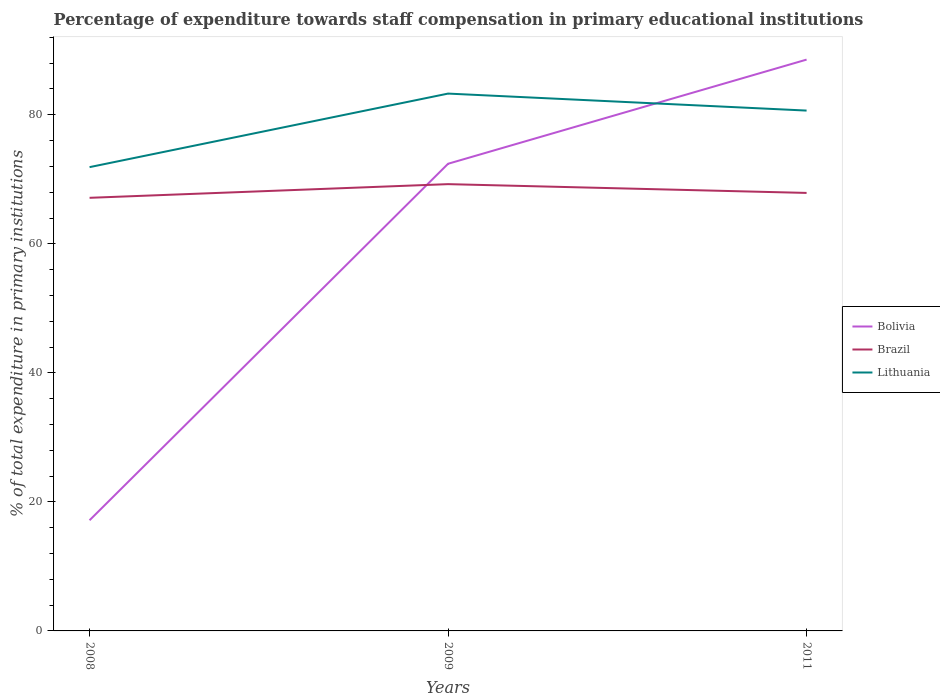How many different coloured lines are there?
Your answer should be compact. 3. Across all years, what is the maximum percentage of expenditure towards staff compensation in Bolivia?
Provide a short and direct response. 17.15. In which year was the percentage of expenditure towards staff compensation in Lithuania maximum?
Offer a very short reply. 2008. What is the total percentage of expenditure towards staff compensation in Bolivia in the graph?
Your answer should be very brief. -16.14. What is the difference between the highest and the second highest percentage of expenditure towards staff compensation in Brazil?
Offer a terse response. 2.12. Is the percentage of expenditure towards staff compensation in Brazil strictly greater than the percentage of expenditure towards staff compensation in Lithuania over the years?
Offer a very short reply. Yes. How many lines are there?
Your response must be concise. 3. What is the difference between two consecutive major ticks on the Y-axis?
Provide a short and direct response. 20. Are the values on the major ticks of Y-axis written in scientific E-notation?
Provide a succinct answer. No. Does the graph contain any zero values?
Give a very brief answer. No. How many legend labels are there?
Your answer should be compact. 3. What is the title of the graph?
Your answer should be very brief. Percentage of expenditure towards staff compensation in primary educational institutions. What is the label or title of the Y-axis?
Offer a very short reply. % of total expenditure in primary institutions. What is the % of total expenditure in primary institutions in Bolivia in 2008?
Make the answer very short. 17.15. What is the % of total expenditure in primary institutions of Brazil in 2008?
Offer a very short reply. 67.13. What is the % of total expenditure in primary institutions in Lithuania in 2008?
Keep it short and to the point. 71.89. What is the % of total expenditure in primary institutions of Bolivia in 2009?
Provide a succinct answer. 72.41. What is the % of total expenditure in primary institutions of Brazil in 2009?
Give a very brief answer. 69.25. What is the % of total expenditure in primary institutions in Lithuania in 2009?
Make the answer very short. 83.29. What is the % of total expenditure in primary institutions of Bolivia in 2011?
Your response must be concise. 88.55. What is the % of total expenditure in primary institutions in Brazil in 2011?
Your response must be concise. 67.89. What is the % of total expenditure in primary institutions in Lithuania in 2011?
Ensure brevity in your answer.  80.66. Across all years, what is the maximum % of total expenditure in primary institutions in Bolivia?
Provide a succinct answer. 88.55. Across all years, what is the maximum % of total expenditure in primary institutions of Brazil?
Keep it short and to the point. 69.25. Across all years, what is the maximum % of total expenditure in primary institutions in Lithuania?
Keep it short and to the point. 83.29. Across all years, what is the minimum % of total expenditure in primary institutions of Bolivia?
Provide a short and direct response. 17.15. Across all years, what is the minimum % of total expenditure in primary institutions of Brazil?
Offer a very short reply. 67.13. Across all years, what is the minimum % of total expenditure in primary institutions in Lithuania?
Keep it short and to the point. 71.89. What is the total % of total expenditure in primary institutions of Bolivia in the graph?
Your response must be concise. 178.12. What is the total % of total expenditure in primary institutions of Brazil in the graph?
Keep it short and to the point. 204.27. What is the total % of total expenditure in primary institutions of Lithuania in the graph?
Offer a very short reply. 235.83. What is the difference between the % of total expenditure in primary institutions of Bolivia in 2008 and that in 2009?
Provide a succinct answer. -55.26. What is the difference between the % of total expenditure in primary institutions of Brazil in 2008 and that in 2009?
Your answer should be very brief. -2.12. What is the difference between the % of total expenditure in primary institutions of Lithuania in 2008 and that in 2009?
Provide a short and direct response. -11.4. What is the difference between the % of total expenditure in primary institutions of Bolivia in 2008 and that in 2011?
Ensure brevity in your answer.  -71.4. What is the difference between the % of total expenditure in primary institutions of Brazil in 2008 and that in 2011?
Give a very brief answer. -0.76. What is the difference between the % of total expenditure in primary institutions of Lithuania in 2008 and that in 2011?
Offer a very short reply. -8.77. What is the difference between the % of total expenditure in primary institutions of Bolivia in 2009 and that in 2011?
Provide a short and direct response. -16.14. What is the difference between the % of total expenditure in primary institutions of Brazil in 2009 and that in 2011?
Make the answer very short. 1.36. What is the difference between the % of total expenditure in primary institutions of Lithuania in 2009 and that in 2011?
Provide a succinct answer. 2.63. What is the difference between the % of total expenditure in primary institutions in Bolivia in 2008 and the % of total expenditure in primary institutions in Brazil in 2009?
Make the answer very short. -52.1. What is the difference between the % of total expenditure in primary institutions in Bolivia in 2008 and the % of total expenditure in primary institutions in Lithuania in 2009?
Keep it short and to the point. -66.13. What is the difference between the % of total expenditure in primary institutions in Brazil in 2008 and the % of total expenditure in primary institutions in Lithuania in 2009?
Keep it short and to the point. -16.16. What is the difference between the % of total expenditure in primary institutions in Bolivia in 2008 and the % of total expenditure in primary institutions in Brazil in 2011?
Your answer should be very brief. -50.74. What is the difference between the % of total expenditure in primary institutions of Bolivia in 2008 and the % of total expenditure in primary institutions of Lithuania in 2011?
Provide a succinct answer. -63.5. What is the difference between the % of total expenditure in primary institutions in Brazil in 2008 and the % of total expenditure in primary institutions in Lithuania in 2011?
Your answer should be very brief. -13.52. What is the difference between the % of total expenditure in primary institutions of Bolivia in 2009 and the % of total expenditure in primary institutions of Brazil in 2011?
Provide a succinct answer. 4.52. What is the difference between the % of total expenditure in primary institutions of Bolivia in 2009 and the % of total expenditure in primary institutions of Lithuania in 2011?
Offer a very short reply. -8.24. What is the difference between the % of total expenditure in primary institutions of Brazil in 2009 and the % of total expenditure in primary institutions of Lithuania in 2011?
Offer a terse response. -11.4. What is the average % of total expenditure in primary institutions in Bolivia per year?
Your answer should be very brief. 59.37. What is the average % of total expenditure in primary institutions in Brazil per year?
Ensure brevity in your answer.  68.09. What is the average % of total expenditure in primary institutions of Lithuania per year?
Offer a very short reply. 78.61. In the year 2008, what is the difference between the % of total expenditure in primary institutions of Bolivia and % of total expenditure in primary institutions of Brazil?
Offer a terse response. -49.98. In the year 2008, what is the difference between the % of total expenditure in primary institutions of Bolivia and % of total expenditure in primary institutions of Lithuania?
Offer a terse response. -54.73. In the year 2008, what is the difference between the % of total expenditure in primary institutions of Brazil and % of total expenditure in primary institutions of Lithuania?
Provide a succinct answer. -4.76. In the year 2009, what is the difference between the % of total expenditure in primary institutions of Bolivia and % of total expenditure in primary institutions of Brazil?
Your answer should be compact. 3.16. In the year 2009, what is the difference between the % of total expenditure in primary institutions of Bolivia and % of total expenditure in primary institutions of Lithuania?
Offer a very short reply. -10.88. In the year 2009, what is the difference between the % of total expenditure in primary institutions in Brazil and % of total expenditure in primary institutions in Lithuania?
Provide a succinct answer. -14.04. In the year 2011, what is the difference between the % of total expenditure in primary institutions in Bolivia and % of total expenditure in primary institutions in Brazil?
Offer a terse response. 20.66. In the year 2011, what is the difference between the % of total expenditure in primary institutions in Bolivia and % of total expenditure in primary institutions in Lithuania?
Ensure brevity in your answer.  7.9. In the year 2011, what is the difference between the % of total expenditure in primary institutions of Brazil and % of total expenditure in primary institutions of Lithuania?
Keep it short and to the point. -12.77. What is the ratio of the % of total expenditure in primary institutions in Bolivia in 2008 to that in 2009?
Provide a succinct answer. 0.24. What is the ratio of the % of total expenditure in primary institutions in Brazil in 2008 to that in 2009?
Provide a short and direct response. 0.97. What is the ratio of the % of total expenditure in primary institutions in Lithuania in 2008 to that in 2009?
Provide a short and direct response. 0.86. What is the ratio of the % of total expenditure in primary institutions in Bolivia in 2008 to that in 2011?
Offer a very short reply. 0.19. What is the ratio of the % of total expenditure in primary institutions in Lithuania in 2008 to that in 2011?
Provide a succinct answer. 0.89. What is the ratio of the % of total expenditure in primary institutions in Bolivia in 2009 to that in 2011?
Give a very brief answer. 0.82. What is the ratio of the % of total expenditure in primary institutions of Brazil in 2009 to that in 2011?
Your response must be concise. 1.02. What is the ratio of the % of total expenditure in primary institutions in Lithuania in 2009 to that in 2011?
Keep it short and to the point. 1.03. What is the difference between the highest and the second highest % of total expenditure in primary institutions of Bolivia?
Your response must be concise. 16.14. What is the difference between the highest and the second highest % of total expenditure in primary institutions of Brazil?
Your answer should be very brief. 1.36. What is the difference between the highest and the second highest % of total expenditure in primary institutions of Lithuania?
Ensure brevity in your answer.  2.63. What is the difference between the highest and the lowest % of total expenditure in primary institutions in Bolivia?
Your answer should be compact. 71.4. What is the difference between the highest and the lowest % of total expenditure in primary institutions in Brazil?
Ensure brevity in your answer.  2.12. What is the difference between the highest and the lowest % of total expenditure in primary institutions of Lithuania?
Your response must be concise. 11.4. 